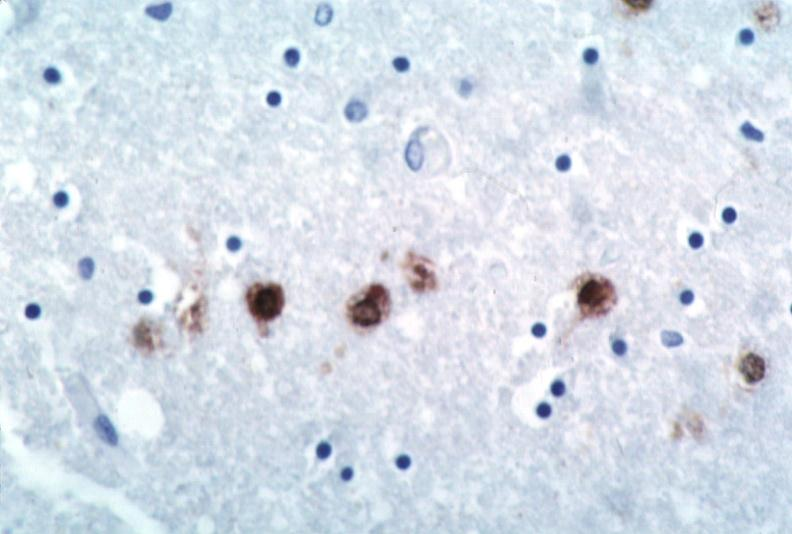does this image show brain, herpes encephalitis?
Answer the question using a single word or phrase. Yes 